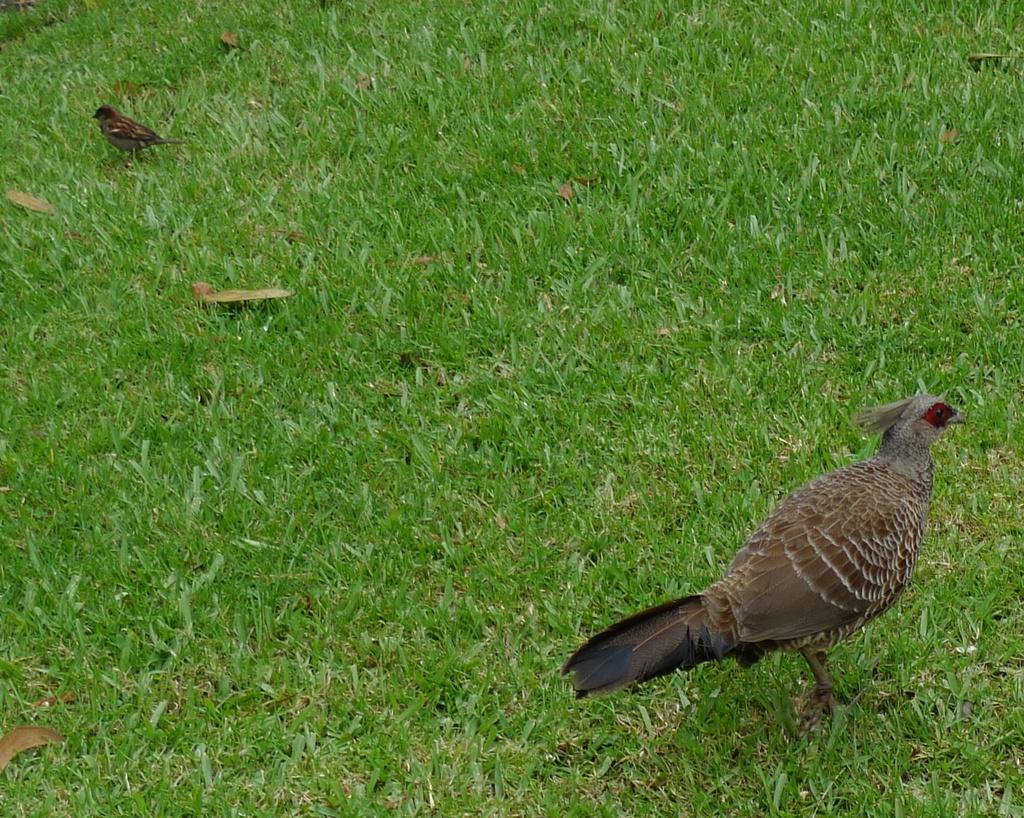What type of animals are on the ground in the image? There are birds on the ground in the image. What type of vegetation can be seen in the image? There is grass visible in the image. What is the root of the bird in the image? There is no root associated with the birds in the image, as they are not plants. 